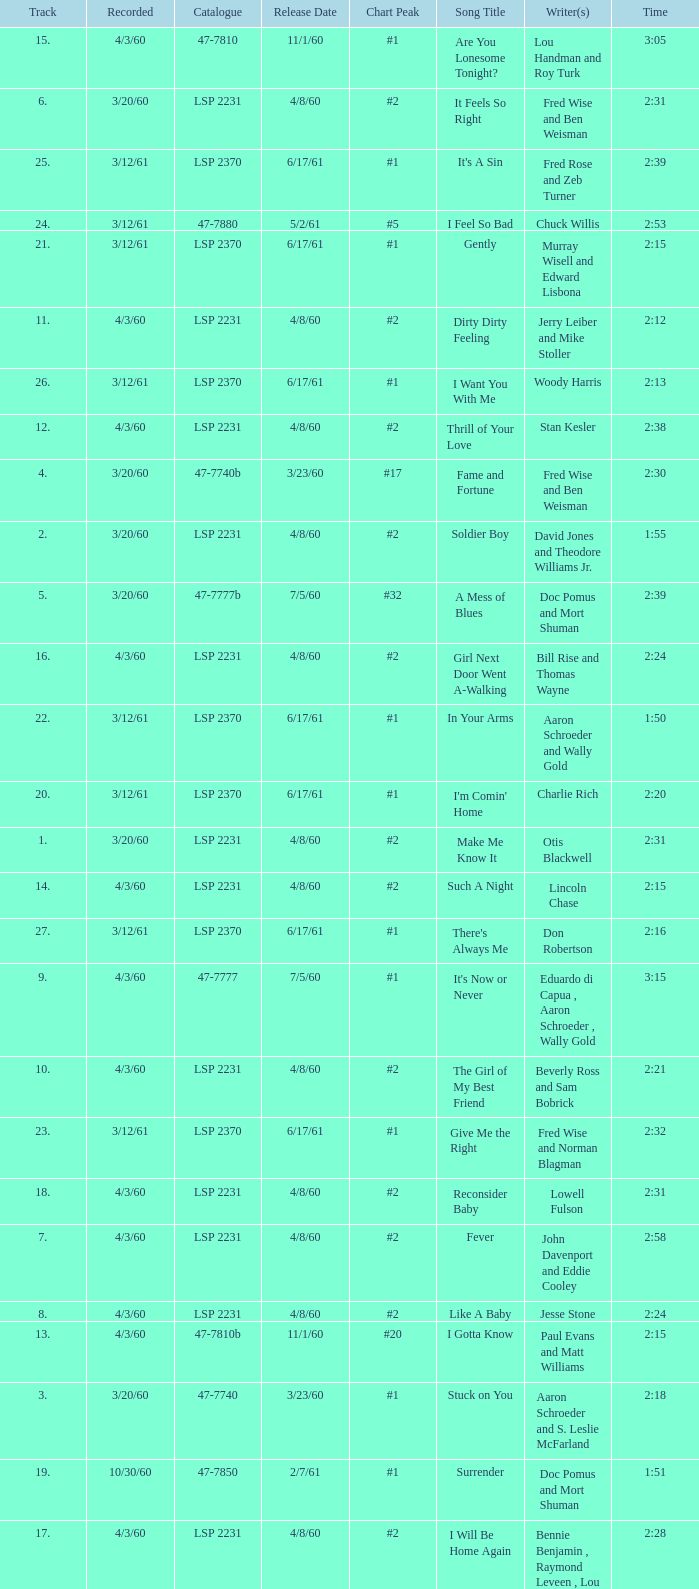On songs with track numbers smaller than number 17 and catalogues of LSP 2231, who are the writer(s)? Otis Blackwell, David Jones and Theodore Williams Jr., Fred Wise and Ben Weisman, John Davenport and Eddie Cooley, Jesse Stone, Beverly Ross and Sam Bobrick, Jerry Leiber and Mike Stoller, Stan Kesler, Lincoln Chase, Bill Rise and Thomas Wayne. 